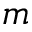Convert formula to latex. <formula><loc_0><loc_0><loc_500><loc_500>m</formula> 